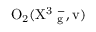Convert formula to latex. <formula><loc_0><loc_0><loc_500><loc_500>O _ { 2 } ( X ^ { 3 } \Sigma _ { g } ^ { - } , v )</formula> 